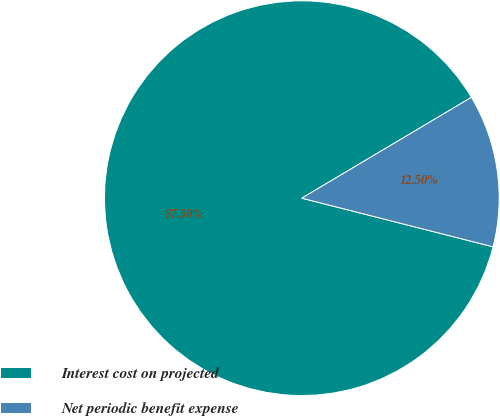Convert chart. <chart><loc_0><loc_0><loc_500><loc_500><pie_chart><fcel>Interest cost on projected<fcel>Net periodic benefit expense<nl><fcel>87.5%<fcel>12.5%<nl></chart> 